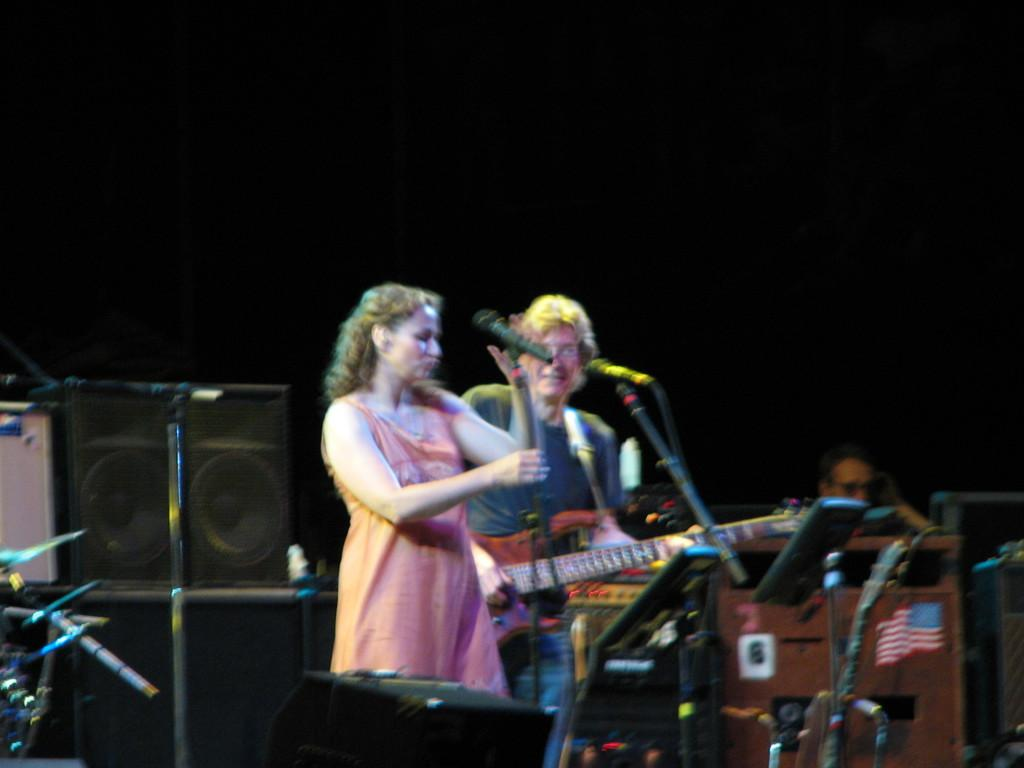What is the woman in the image doing? The woman is standing in the image and holding a mic with a stand. What is the person with the woman holding? The person is holding a guitar in the image. Can you describe the equipment used for amplifying sound in the image? There is a mic with a stand and speaker boxes in the image. How many people are visible in the image? There is a woman and a person holding a guitar visible in the image. What additional object can be seen in the image? There is a flag in the image. What type of protest is being held in the image? There is no indication of a protest in the image; it features a woman holding a mic with a stand and a person holding a guitar. Is there a prison visible in the image? There is no prison present in the image. 